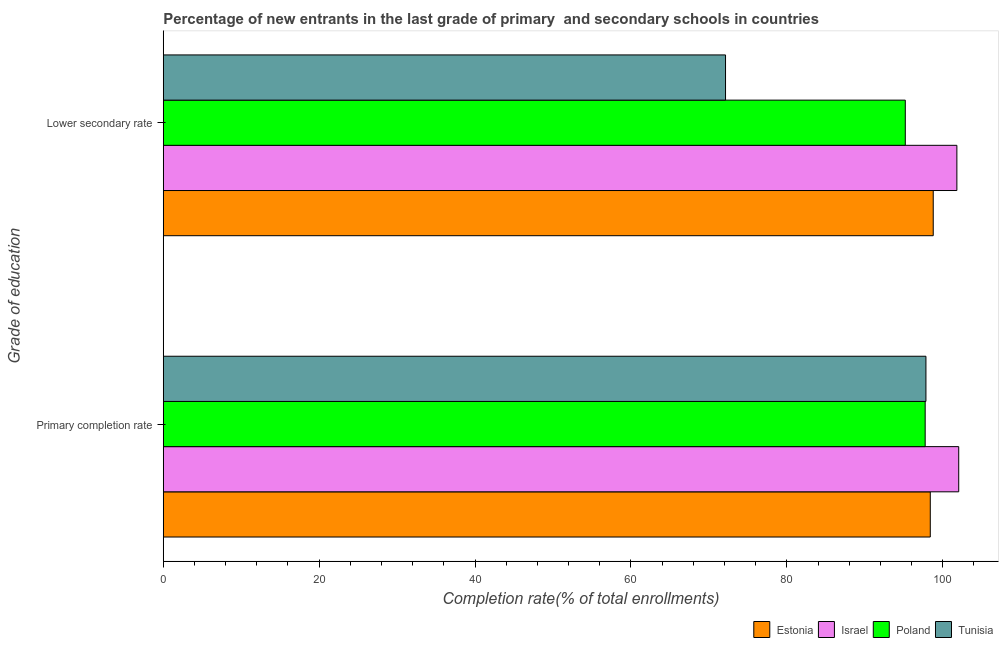How many different coloured bars are there?
Make the answer very short. 4. How many bars are there on the 1st tick from the bottom?
Provide a short and direct response. 4. What is the label of the 2nd group of bars from the top?
Give a very brief answer. Primary completion rate. What is the completion rate in secondary schools in Estonia?
Your response must be concise. 98.78. Across all countries, what is the maximum completion rate in primary schools?
Offer a terse response. 102.05. Across all countries, what is the minimum completion rate in secondary schools?
Provide a short and direct response. 72.13. In which country was the completion rate in secondary schools minimum?
Your response must be concise. Tunisia. What is the total completion rate in primary schools in the graph?
Your answer should be very brief. 396.03. What is the difference between the completion rate in primary schools in Estonia and that in Poland?
Offer a very short reply. 0.66. What is the difference between the completion rate in primary schools in Tunisia and the completion rate in secondary schools in Estonia?
Provide a succinct answer. -0.94. What is the average completion rate in secondary schools per country?
Make the answer very short. 91.98. What is the difference between the completion rate in primary schools and completion rate in secondary schools in Israel?
Offer a terse response. 0.24. What is the ratio of the completion rate in primary schools in Estonia to that in Tunisia?
Your response must be concise. 1.01. What does the 2nd bar from the top in Primary completion rate represents?
Provide a short and direct response. Poland. What does the 4th bar from the bottom in Lower secondary rate represents?
Your answer should be compact. Tunisia. Are all the bars in the graph horizontal?
Keep it short and to the point. Yes. How many countries are there in the graph?
Provide a short and direct response. 4. Are the values on the major ticks of X-axis written in scientific E-notation?
Provide a succinct answer. No. Does the graph contain any zero values?
Provide a short and direct response. No. Does the graph contain grids?
Provide a succinct answer. No. How are the legend labels stacked?
Your response must be concise. Horizontal. What is the title of the graph?
Your answer should be very brief. Percentage of new entrants in the last grade of primary  and secondary schools in countries. Does "High income" appear as one of the legend labels in the graph?
Offer a terse response. No. What is the label or title of the X-axis?
Your answer should be compact. Completion rate(% of total enrollments). What is the label or title of the Y-axis?
Ensure brevity in your answer.  Grade of education. What is the Completion rate(% of total enrollments) in Estonia in Primary completion rate?
Offer a very short reply. 98.4. What is the Completion rate(% of total enrollments) in Israel in Primary completion rate?
Provide a short and direct response. 102.05. What is the Completion rate(% of total enrollments) of Poland in Primary completion rate?
Offer a very short reply. 97.74. What is the Completion rate(% of total enrollments) in Tunisia in Primary completion rate?
Provide a succinct answer. 97.84. What is the Completion rate(% of total enrollments) of Estonia in Lower secondary rate?
Offer a terse response. 98.78. What is the Completion rate(% of total enrollments) of Israel in Lower secondary rate?
Your response must be concise. 101.81. What is the Completion rate(% of total enrollments) of Poland in Lower secondary rate?
Ensure brevity in your answer.  95.19. What is the Completion rate(% of total enrollments) of Tunisia in Lower secondary rate?
Provide a succinct answer. 72.13. Across all Grade of education, what is the maximum Completion rate(% of total enrollments) of Estonia?
Your answer should be very brief. 98.78. Across all Grade of education, what is the maximum Completion rate(% of total enrollments) in Israel?
Your response must be concise. 102.05. Across all Grade of education, what is the maximum Completion rate(% of total enrollments) of Poland?
Offer a terse response. 97.74. Across all Grade of education, what is the maximum Completion rate(% of total enrollments) in Tunisia?
Your answer should be very brief. 97.84. Across all Grade of education, what is the minimum Completion rate(% of total enrollments) in Estonia?
Make the answer very short. 98.4. Across all Grade of education, what is the minimum Completion rate(% of total enrollments) in Israel?
Your answer should be compact. 101.81. Across all Grade of education, what is the minimum Completion rate(% of total enrollments) in Poland?
Give a very brief answer. 95.19. Across all Grade of education, what is the minimum Completion rate(% of total enrollments) in Tunisia?
Provide a succinct answer. 72.13. What is the total Completion rate(% of total enrollments) of Estonia in the graph?
Offer a terse response. 197.17. What is the total Completion rate(% of total enrollments) of Israel in the graph?
Provide a succinct answer. 203.86. What is the total Completion rate(% of total enrollments) of Poland in the graph?
Make the answer very short. 192.93. What is the total Completion rate(% of total enrollments) of Tunisia in the graph?
Ensure brevity in your answer.  169.97. What is the difference between the Completion rate(% of total enrollments) in Estonia in Primary completion rate and that in Lower secondary rate?
Your response must be concise. -0.38. What is the difference between the Completion rate(% of total enrollments) of Israel in Primary completion rate and that in Lower secondary rate?
Provide a short and direct response. 0.24. What is the difference between the Completion rate(% of total enrollments) of Poland in Primary completion rate and that in Lower secondary rate?
Your answer should be very brief. 2.55. What is the difference between the Completion rate(% of total enrollments) of Tunisia in Primary completion rate and that in Lower secondary rate?
Your response must be concise. 25.71. What is the difference between the Completion rate(% of total enrollments) of Estonia in Primary completion rate and the Completion rate(% of total enrollments) of Israel in Lower secondary rate?
Offer a very short reply. -3.41. What is the difference between the Completion rate(% of total enrollments) in Estonia in Primary completion rate and the Completion rate(% of total enrollments) in Poland in Lower secondary rate?
Your answer should be very brief. 3.21. What is the difference between the Completion rate(% of total enrollments) in Estonia in Primary completion rate and the Completion rate(% of total enrollments) in Tunisia in Lower secondary rate?
Ensure brevity in your answer.  26.27. What is the difference between the Completion rate(% of total enrollments) of Israel in Primary completion rate and the Completion rate(% of total enrollments) of Poland in Lower secondary rate?
Make the answer very short. 6.85. What is the difference between the Completion rate(% of total enrollments) of Israel in Primary completion rate and the Completion rate(% of total enrollments) of Tunisia in Lower secondary rate?
Your answer should be very brief. 29.92. What is the difference between the Completion rate(% of total enrollments) of Poland in Primary completion rate and the Completion rate(% of total enrollments) of Tunisia in Lower secondary rate?
Keep it short and to the point. 25.61. What is the average Completion rate(% of total enrollments) of Estonia per Grade of education?
Offer a very short reply. 98.59. What is the average Completion rate(% of total enrollments) of Israel per Grade of education?
Ensure brevity in your answer.  101.93. What is the average Completion rate(% of total enrollments) in Poland per Grade of education?
Keep it short and to the point. 96.47. What is the average Completion rate(% of total enrollments) in Tunisia per Grade of education?
Make the answer very short. 84.99. What is the difference between the Completion rate(% of total enrollments) of Estonia and Completion rate(% of total enrollments) of Israel in Primary completion rate?
Make the answer very short. -3.65. What is the difference between the Completion rate(% of total enrollments) in Estonia and Completion rate(% of total enrollments) in Poland in Primary completion rate?
Your response must be concise. 0.66. What is the difference between the Completion rate(% of total enrollments) of Estonia and Completion rate(% of total enrollments) of Tunisia in Primary completion rate?
Keep it short and to the point. 0.56. What is the difference between the Completion rate(% of total enrollments) of Israel and Completion rate(% of total enrollments) of Poland in Primary completion rate?
Offer a very short reply. 4.3. What is the difference between the Completion rate(% of total enrollments) in Israel and Completion rate(% of total enrollments) in Tunisia in Primary completion rate?
Give a very brief answer. 4.21. What is the difference between the Completion rate(% of total enrollments) of Poland and Completion rate(% of total enrollments) of Tunisia in Primary completion rate?
Give a very brief answer. -0.1. What is the difference between the Completion rate(% of total enrollments) of Estonia and Completion rate(% of total enrollments) of Israel in Lower secondary rate?
Keep it short and to the point. -3.03. What is the difference between the Completion rate(% of total enrollments) in Estonia and Completion rate(% of total enrollments) in Poland in Lower secondary rate?
Offer a terse response. 3.59. What is the difference between the Completion rate(% of total enrollments) in Estonia and Completion rate(% of total enrollments) in Tunisia in Lower secondary rate?
Your answer should be compact. 26.65. What is the difference between the Completion rate(% of total enrollments) in Israel and Completion rate(% of total enrollments) in Poland in Lower secondary rate?
Your answer should be very brief. 6.62. What is the difference between the Completion rate(% of total enrollments) in Israel and Completion rate(% of total enrollments) in Tunisia in Lower secondary rate?
Provide a short and direct response. 29.68. What is the difference between the Completion rate(% of total enrollments) of Poland and Completion rate(% of total enrollments) of Tunisia in Lower secondary rate?
Provide a short and direct response. 23.06. What is the ratio of the Completion rate(% of total enrollments) of Poland in Primary completion rate to that in Lower secondary rate?
Your response must be concise. 1.03. What is the ratio of the Completion rate(% of total enrollments) of Tunisia in Primary completion rate to that in Lower secondary rate?
Make the answer very short. 1.36. What is the difference between the highest and the second highest Completion rate(% of total enrollments) in Estonia?
Offer a very short reply. 0.38. What is the difference between the highest and the second highest Completion rate(% of total enrollments) in Israel?
Make the answer very short. 0.24. What is the difference between the highest and the second highest Completion rate(% of total enrollments) in Poland?
Make the answer very short. 2.55. What is the difference between the highest and the second highest Completion rate(% of total enrollments) of Tunisia?
Offer a terse response. 25.71. What is the difference between the highest and the lowest Completion rate(% of total enrollments) of Estonia?
Your answer should be compact. 0.38. What is the difference between the highest and the lowest Completion rate(% of total enrollments) in Israel?
Make the answer very short. 0.24. What is the difference between the highest and the lowest Completion rate(% of total enrollments) in Poland?
Keep it short and to the point. 2.55. What is the difference between the highest and the lowest Completion rate(% of total enrollments) in Tunisia?
Your answer should be compact. 25.71. 